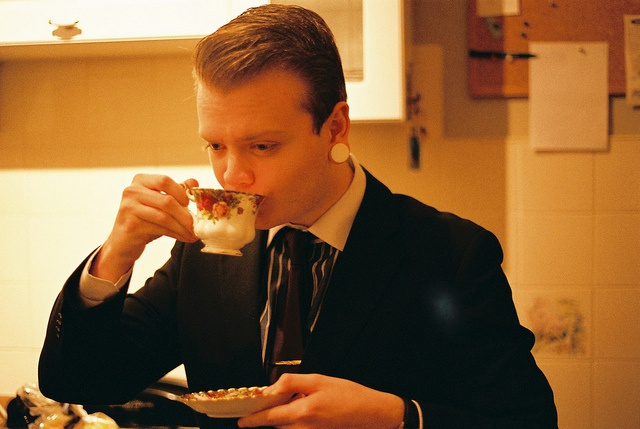Describe the objects in this image and their specific colors. I can see people in lightyellow, black, brown, red, and maroon tones, cup in lightyellow, orange, and brown tones, and tie in lightyellow, black, maroon, brown, and orange tones in this image. 